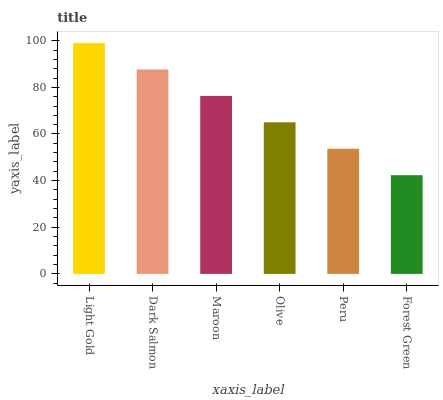Is Dark Salmon the minimum?
Answer yes or no. No. Is Dark Salmon the maximum?
Answer yes or no. No. Is Light Gold greater than Dark Salmon?
Answer yes or no. Yes. Is Dark Salmon less than Light Gold?
Answer yes or no. Yes. Is Dark Salmon greater than Light Gold?
Answer yes or no. No. Is Light Gold less than Dark Salmon?
Answer yes or no. No. Is Maroon the high median?
Answer yes or no. Yes. Is Olive the low median?
Answer yes or no. Yes. Is Peru the high median?
Answer yes or no. No. Is Forest Green the low median?
Answer yes or no. No. 